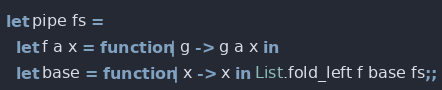<code> <loc_0><loc_0><loc_500><loc_500><_OCaml_>
let pipe fs =
  let f a x = function | g -> g a x in
  let base = function | x -> x in List.fold_left f base fs;;
</code> 